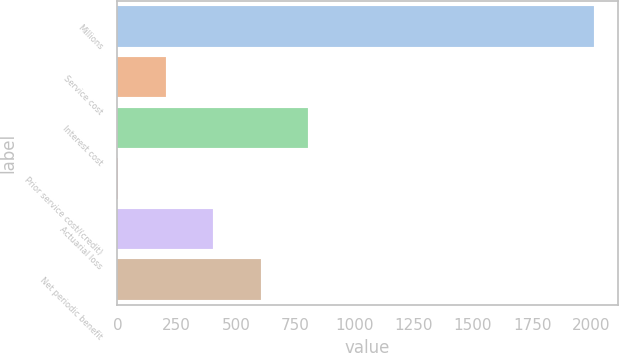Convert chart. <chart><loc_0><loc_0><loc_500><loc_500><bar_chart><fcel>Millions<fcel>Service cost<fcel>Interest cost<fcel>Prior service cost/(credit)<fcel>Actuarial loss<fcel>Net periodic benefit<nl><fcel>2010<fcel>203.7<fcel>805.8<fcel>3<fcel>404.4<fcel>605.1<nl></chart> 